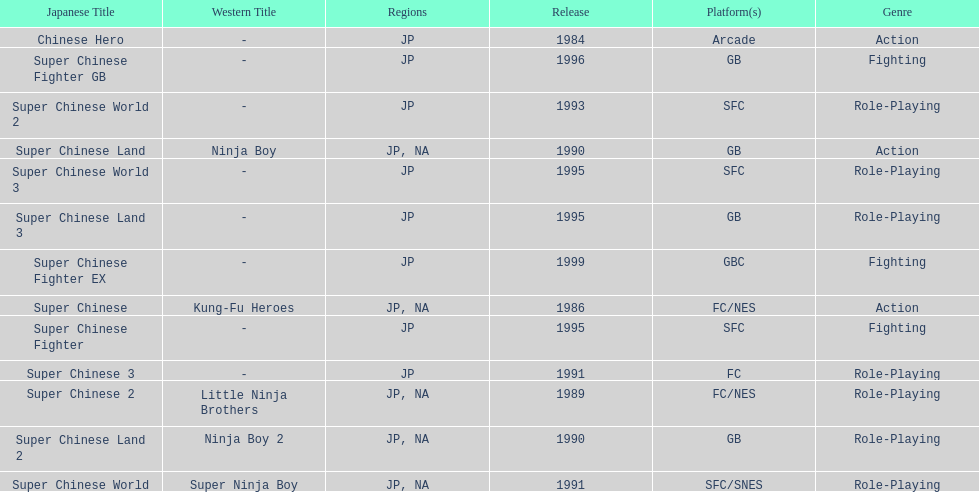What are the total of super chinese games released? 13. 